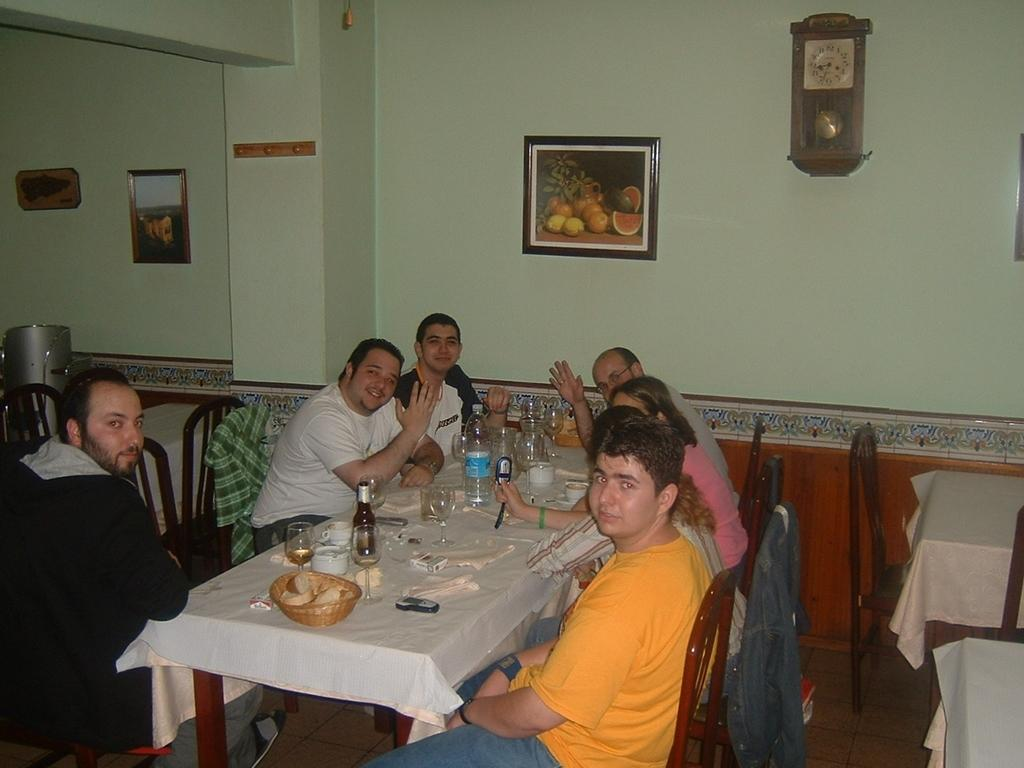What type of structure can be seen in the image? There is a wall in the image. What is hanging on the wall? There is a photo frame in the image. What time-telling device is present in the image? There is a clock in the image. What are the people in the image doing? There are people sitting on chairs in the image. What piece of furniture is present in the image? There is a table in the image. What is on top of the table? There is a basket, a glass, bottles, and a plate on the table. What type of calendar is hanging on the wall in the image? There is no calendar present in the image; only a photo frame is mentioned. What is the yarn used for in the image? There is no yarn present in the image. 